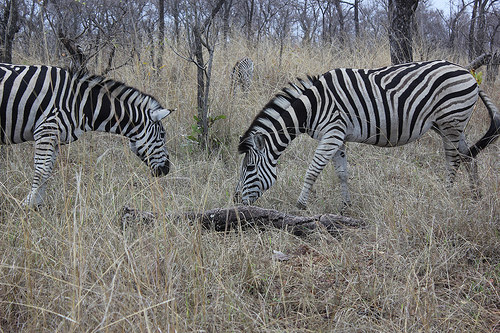Are there any features that help zebras survive in their habitat? Certainly, the zebras’ unique stripes are more than just visually striking; they serve as a natural defense mechanism. The pattern confuses predators and biting flies, and appears to play a role in social interactions among zebras. Additionally, their keen sense of hearing and smell, along with their agility, aid in predator avoidance. 